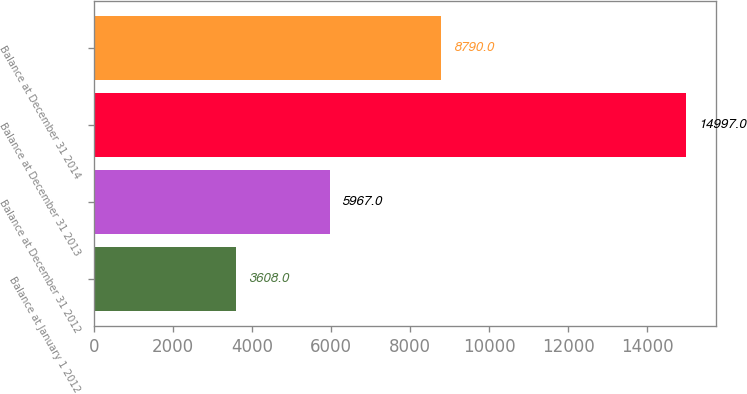Convert chart. <chart><loc_0><loc_0><loc_500><loc_500><bar_chart><fcel>Balance at January 1 2012<fcel>Balance at December 31 2012<fcel>Balance at December 31 2013<fcel>Balance at December 31 2014<nl><fcel>3608<fcel>5967<fcel>14997<fcel>8790<nl></chart> 